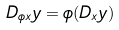Convert formula to latex. <formula><loc_0><loc_0><loc_500><loc_500>D _ { \phi x } y = \phi ( D _ { x } y )</formula> 